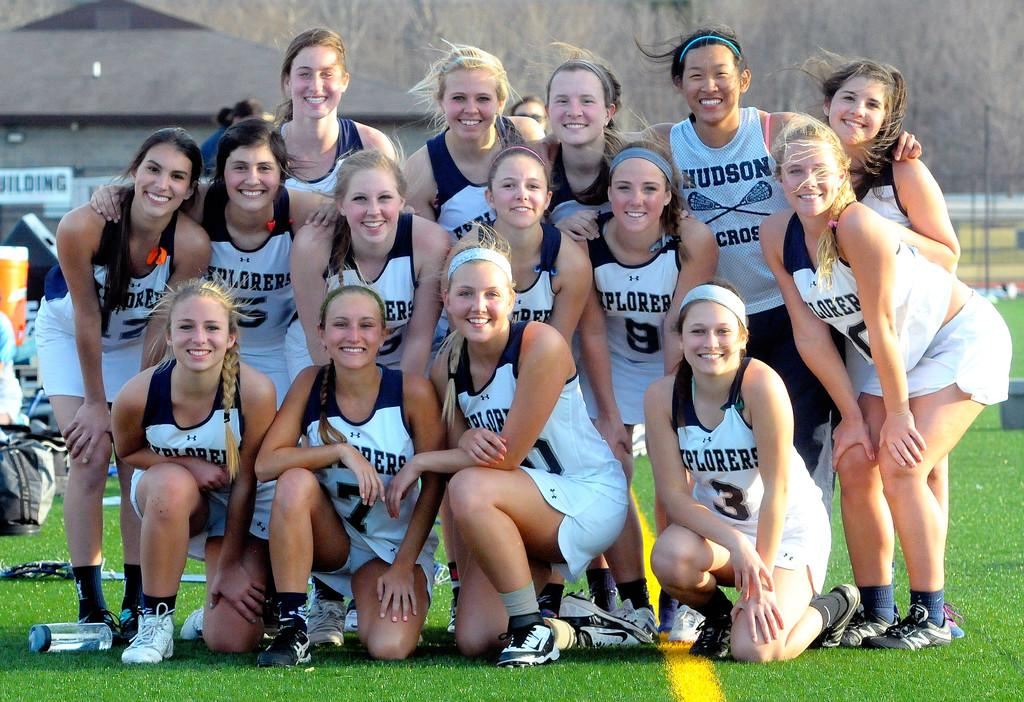<image>
Render a clear and concise summary of the photo. The Explorers lacrosse team poses for a team photo. 